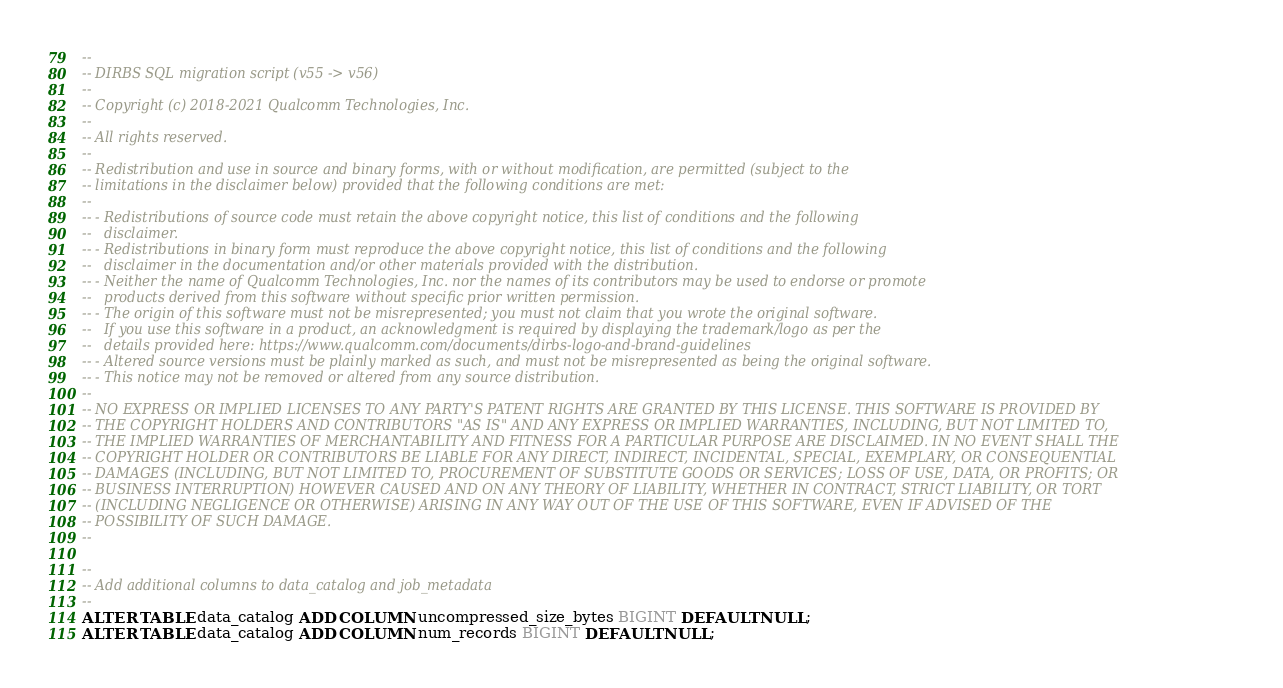<code> <loc_0><loc_0><loc_500><loc_500><_SQL_>--
-- DIRBS SQL migration script (v55 -> v56)
--
-- Copyright (c) 2018-2021 Qualcomm Technologies, Inc.
--
-- All rights reserved.
--
-- Redistribution and use in source and binary forms, with or without modification, are permitted (subject to the
-- limitations in the disclaimer below) provided that the following conditions are met:
--
-- - Redistributions of source code must retain the above copyright notice, this list of conditions and the following
--   disclaimer.
-- - Redistributions in binary form must reproduce the above copyright notice, this list of conditions and the following
--   disclaimer in the documentation and/or other materials provided with the distribution.
-- - Neither the name of Qualcomm Technologies, Inc. nor the names of its contributors may be used to endorse or promote
--   products derived from this software without specific prior written permission.
-- - The origin of this software must not be misrepresented; you must not claim that you wrote the original software.
--   If you use this software in a product, an acknowledgment is required by displaying the trademark/logo as per the
--   details provided here: https://www.qualcomm.com/documents/dirbs-logo-and-brand-guidelines
-- - Altered source versions must be plainly marked as such, and must not be misrepresented as being the original software.
-- - This notice may not be removed or altered from any source distribution.
--
-- NO EXPRESS OR IMPLIED LICENSES TO ANY PARTY'S PATENT RIGHTS ARE GRANTED BY THIS LICENSE. THIS SOFTWARE IS PROVIDED BY
-- THE COPYRIGHT HOLDERS AND CONTRIBUTORS "AS IS" AND ANY EXPRESS OR IMPLIED WARRANTIES, INCLUDING, BUT NOT LIMITED TO,
-- THE IMPLIED WARRANTIES OF MERCHANTABILITY AND FITNESS FOR A PARTICULAR PURPOSE ARE DISCLAIMED. IN NO EVENT SHALL THE
-- COPYRIGHT HOLDER OR CONTRIBUTORS BE LIABLE FOR ANY DIRECT, INDIRECT, INCIDENTAL, SPECIAL, EXEMPLARY, OR CONSEQUENTIAL
-- DAMAGES (INCLUDING, BUT NOT LIMITED TO, PROCUREMENT OF SUBSTITUTE GOODS OR SERVICES; LOSS OF USE, DATA, OR PROFITS; OR
-- BUSINESS INTERRUPTION) HOWEVER CAUSED AND ON ANY THEORY OF LIABILITY, WHETHER IN CONTRACT, STRICT LIABILITY, OR TORT
-- (INCLUDING NEGLIGENCE OR OTHERWISE) ARISING IN ANY WAY OUT OF THE USE OF THIS SOFTWARE, EVEN IF ADVISED OF THE
-- POSSIBILITY OF SUCH DAMAGE.
--

--
-- Add additional columns to data_catalog and job_metadata
--
ALTER TABLE data_catalog ADD COLUMN uncompressed_size_bytes BIGINT DEFAULT NULL;
ALTER TABLE data_catalog ADD COLUMN num_records BIGINT DEFAULT NULL;
</code> 